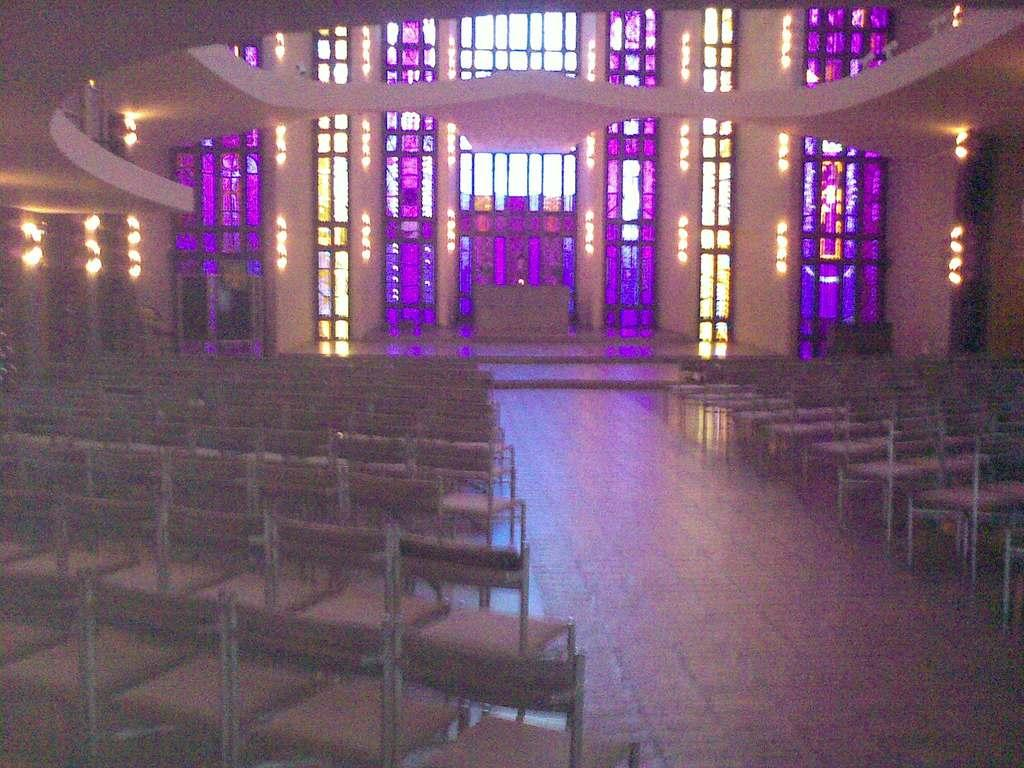What type of furniture is present in the image? There are many chairs in the image. What material are the windows made of in the image? The windows visible in the image are made of glass. What is the relation between the chairs and the jail in the image? There is no jail present in the image, and therefore no relation can be established between the chairs and a jail. 